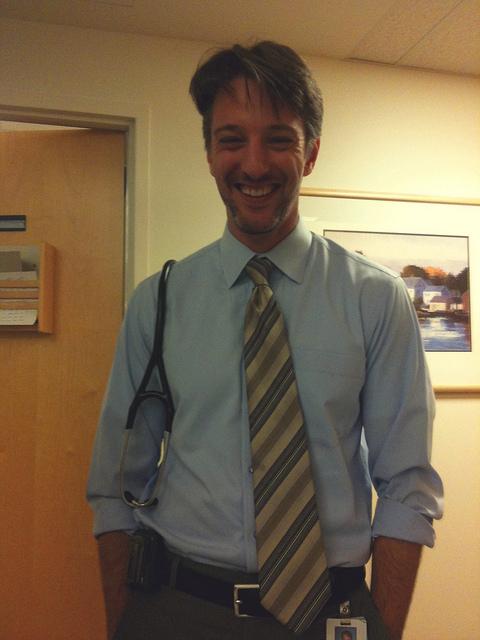What number is on the left door?
Be succinct. 0. Is a window behind the guy?
Write a very short answer. No. Do people usually wear a necktie with that style of shirt?
Concise answer only. Yes. Is the man a waiter?
Short answer required. No. What is on the man's shoulder?
Keep it brief. Stethoscope. Is the man wearing a tie?
Write a very short answer. Yes. Is he professionally dressed?
Write a very short answer. Yes. How many televisions are in the picture?
Be succinct. 0. 